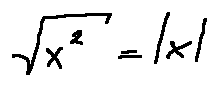Convert formula to latex. <formula><loc_0><loc_0><loc_500><loc_500>\sqrt { x ^ { 2 } } = | x |</formula> 